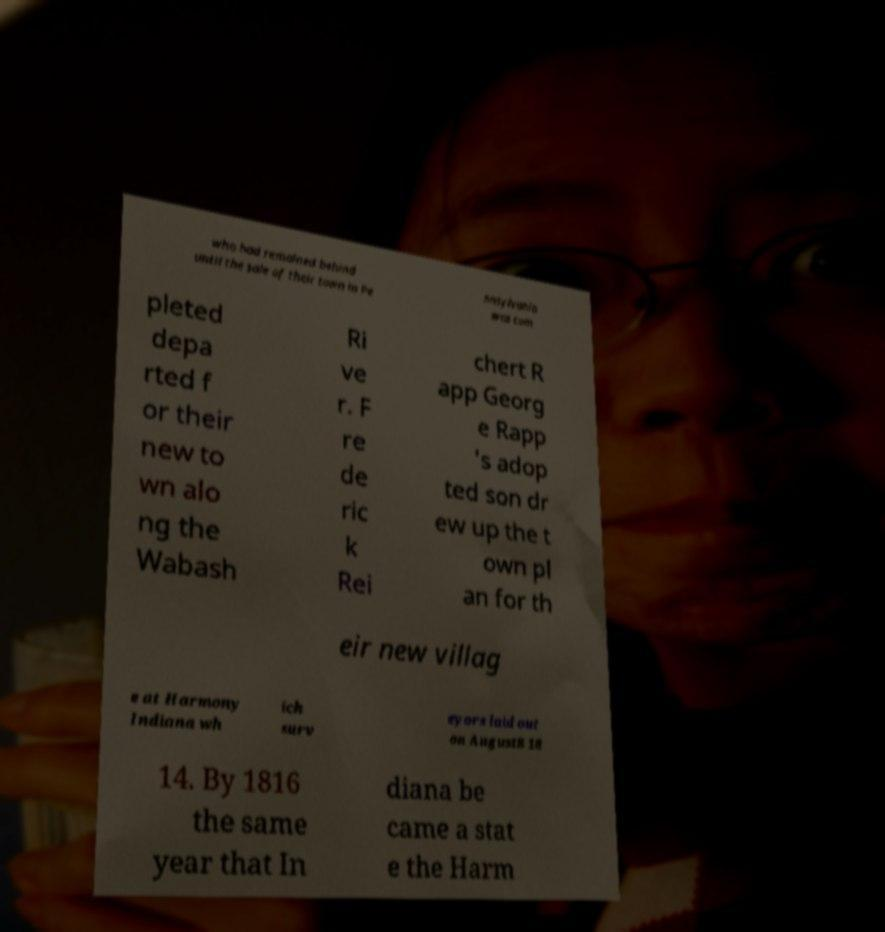Could you extract and type out the text from this image? who had remained behind until the sale of their town in Pe nnsylvania was com pleted depa rted f or their new to wn alo ng the Wabash Ri ve r. F re de ric k Rei chert R app Georg e Rapp 's adop ted son dr ew up the t own pl an for th eir new villag e at Harmony Indiana wh ich surv eyors laid out on August8 18 14. By 1816 the same year that In diana be came a stat e the Harm 